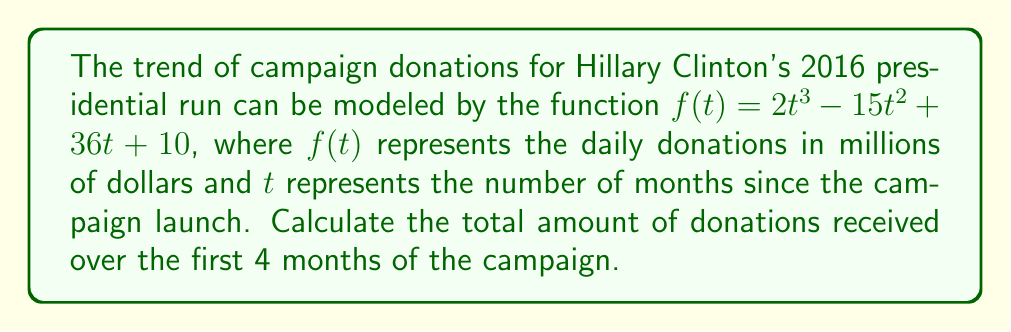Can you answer this question? To find the total amount of donations over the first 4 months, we need to calculate the area under the curve of $f(t)$ from $t=0$ to $t=4$. This can be done using definite integration.

1. Set up the definite integral:
   $$\int_0^4 (2t^3 - 15t^2 + 36t + 10) dt$$

2. Integrate the function:
   $$\left[\frac{1}{2}t^4 - 5t^3 + 18t^2 + 10t\right]_0^4$$

3. Evaluate the integral at the upper and lower bounds:
   Upper bound (t=4):
   $$\frac{1}{2}(4)^4 - 5(4)^3 + 18(4)^2 + 10(4) = 128 - 320 + 288 + 40 = 136$$
   
   Lower bound (t=0):
   $$\frac{1}{2}(0)^4 - 5(0)^3 + 18(0)^2 + 10(0) = 0$$

4. Subtract the lower bound from the upper bound:
   $$136 - 0 = 136$$

The result, 136, represents the total donations in millions of dollars over the first 4 months of the campaign.
Answer: $136 million 